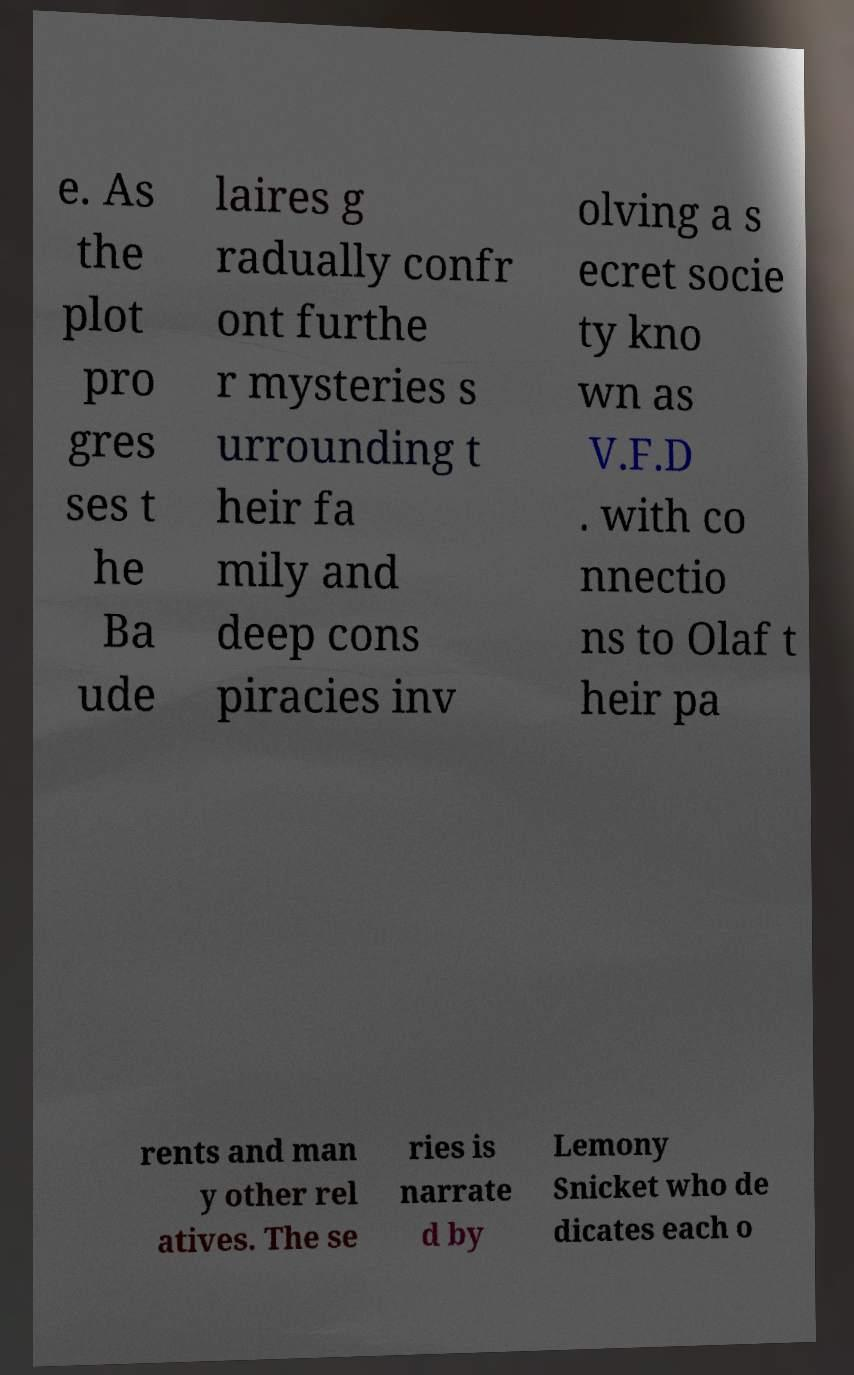Can you read and provide the text displayed in the image?This photo seems to have some interesting text. Can you extract and type it out for me? e. As the plot pro gres ses t he Ba ude laires g radually confr ont furthe r mysteries s urrounding t heir fa mily and deep cons piracies inv olving a s ecret socie ty kno wn as V.F.D . with co nnectio ns to Olaf t heir pa rents and man y other rel atives. The se ries is narrate d by Lemony Snicket who de dicates each o 